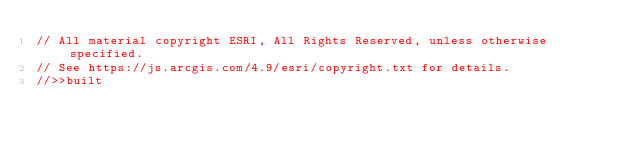Convert code to text. <code><loc_0><loc_0><loc_500><loc_500><_JavaScript_>// All material copyright ESRI, All Rights Reserved, unless otherwise specified.
// See https://js.arcgis.com/4.9/esri/copyright.txt for details.
//>>built</code> 